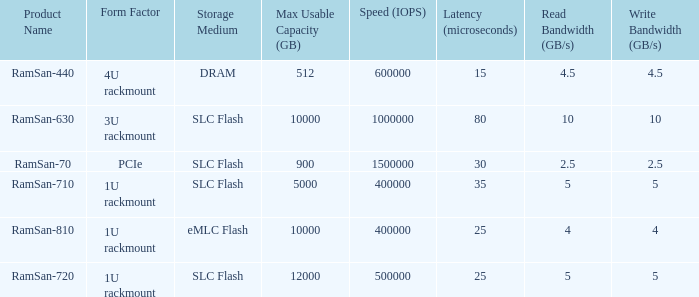What is the ramsan-810 transfer delay? 1.0. 